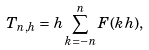<formula> <loc_0><loc_0><loc_500><loc_500>T _ { n , h } = h \sum _ { k = - n } ^ { n } F ( k h ) ,</formula> 